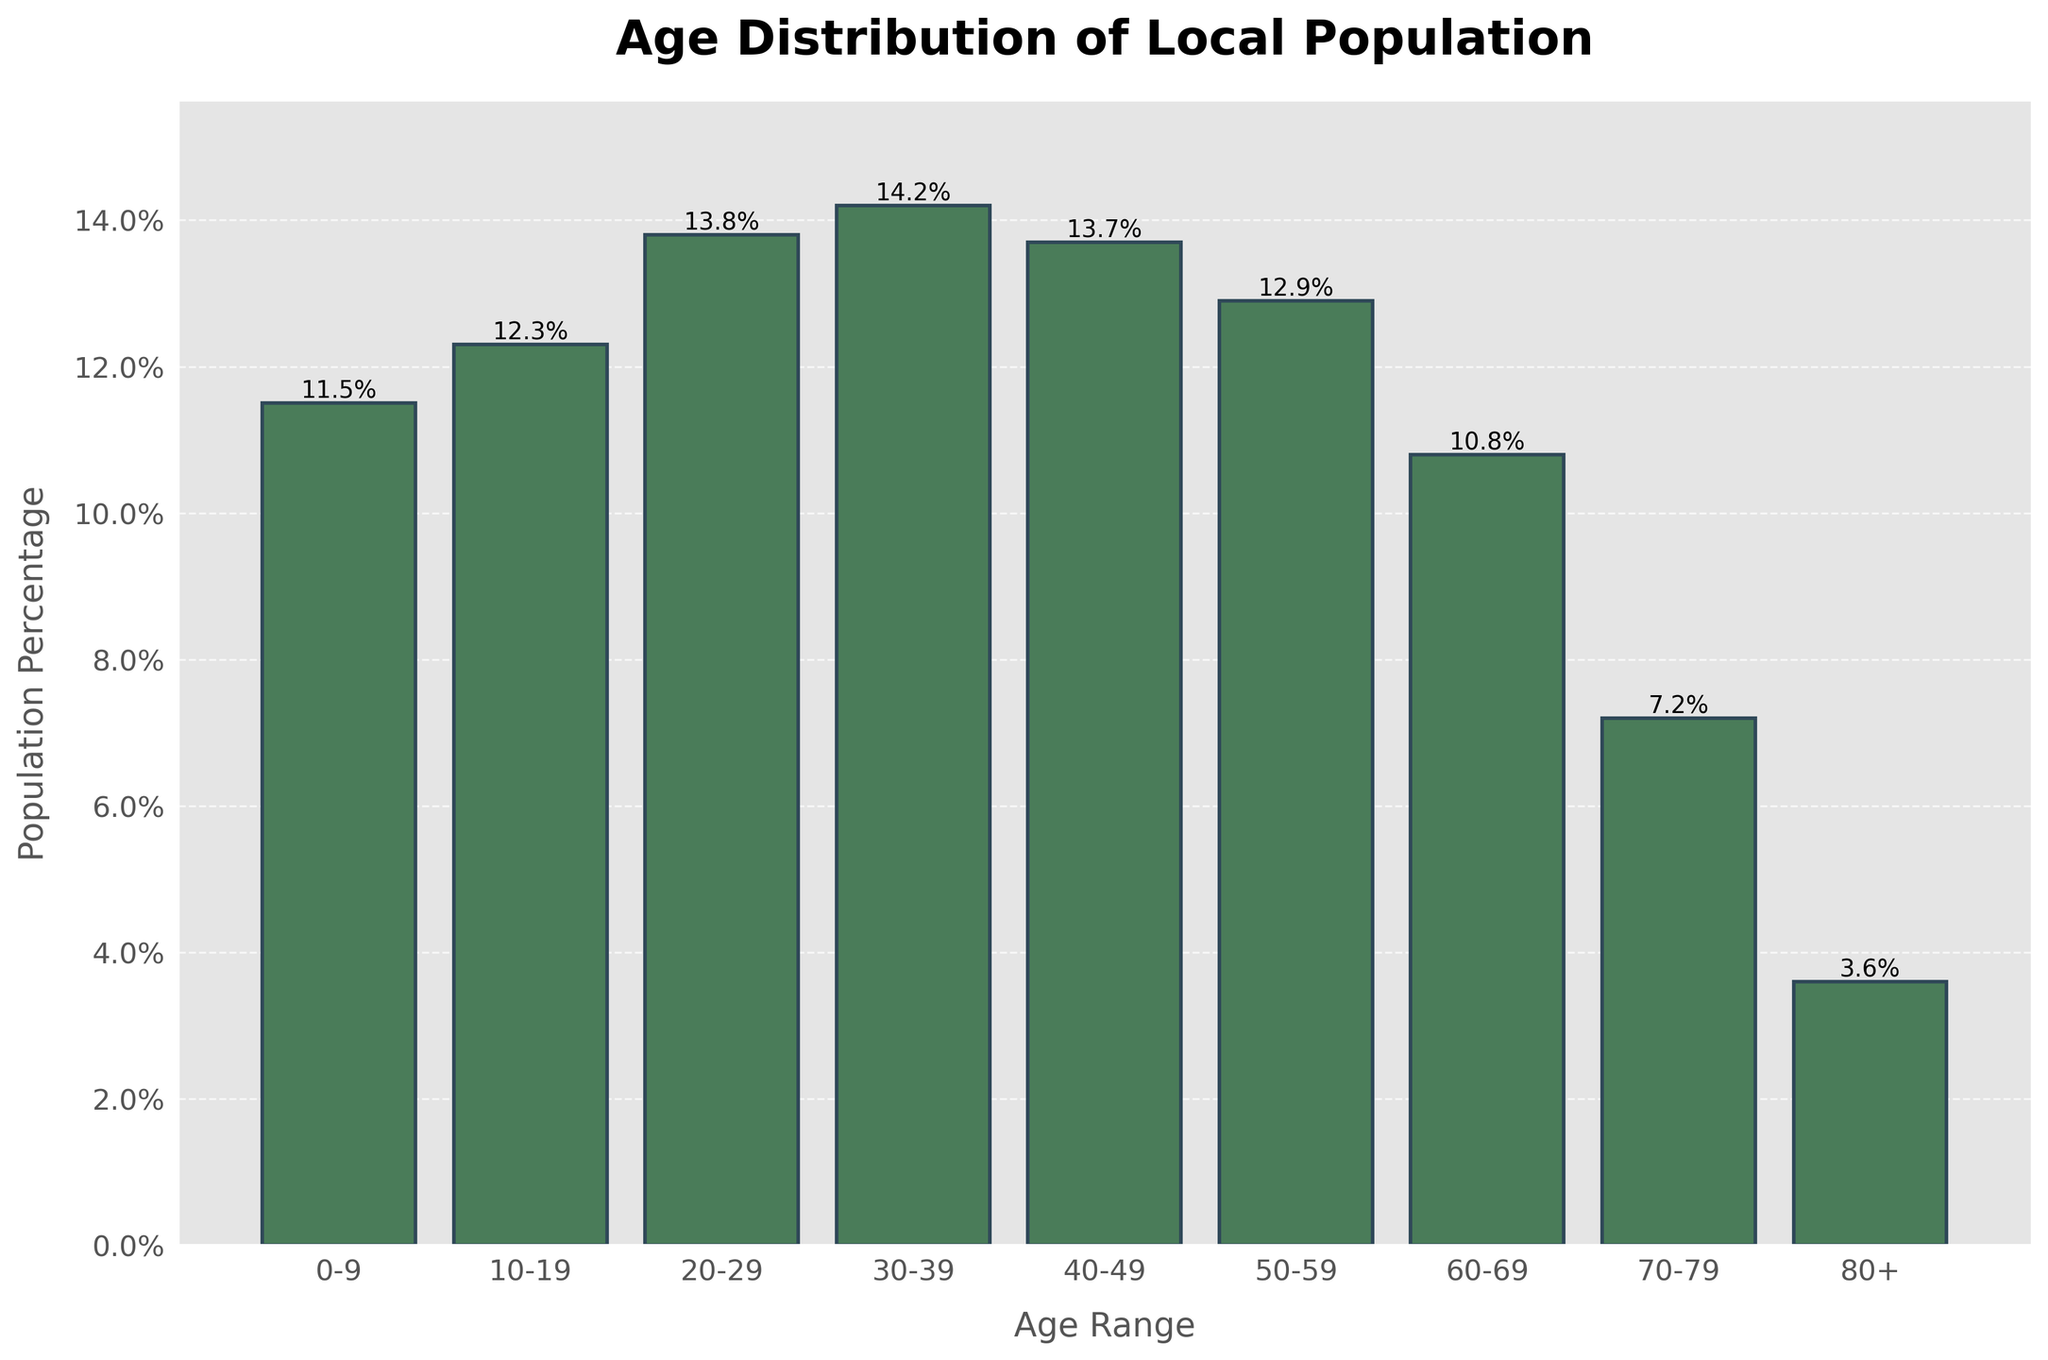What is the age range of the population group with the highest percentage? The bar chart shows the population percentages for each age range, and the tallest bar represents the age range with the highest percentage. In this chart, the bar for the age range 30-39 is the tallest with a population percentage of 14.2%.
Answer: 30-39 Which age ranges have a population percentage greater than 13%? By visually inspecting the bars and their heights, the age ranges with population percentages listed above 13% are 20-29 (13.8%), 30-39 (14.2%), and 40-49 (13.7%).
Answer: 20-29, 30-39, 40-49 What is the combined population percentage for the age ranges 60-69 and 70-79? To find this value, add the population percentages of the age ranges 60-69 (10.8%) and 70-79 (7.2%). The combined percentage is 10.8% + 7.2% = 18.0%.
Answer: 18.0% Which age range has a population percentage closest to 15%? By checking the height of each bar and the numerical values, the age range 30-39 has a population percentage of 14.2%, which is closest to 15%.
Answer: 30-39 How much higher is the population percentage of the 30-39 age range compared to the 80+ age range? The population percentage of age range 30-39 is 14.2%, and for 80+ it is 3.6%. Calculate the difference: 14.2% - 3.6% = 10.6%.
Answer: 10.6% Which age range has the lowest population percentage, and what is that percentage? The shortest bar corresponds to the 80+ age range with a population percentage of 3.6%.
Answer: 80+, 3.6% Are there more people in the age range 10-19 or 50-59? Comparing the heights of the bars for the age ranges 10-19 (12.3%) and 50-59 (12.9%), the bar for 50-59 is slightly taller. Therefore, there are more people in the 50-59 age range.
Answer: 50-59 What is the average population percentage of the age ranges 0-9, 10-19, and 20-29? The population percentages for the age ranges 0-9, 10-19, and 20-29 are 11.5%, 12.3%, and 13.8% respectively. Calculate the average: (11.5% + 12.3% + 13.8%) / 3 = 12.53%.
Answer: 12.53% 